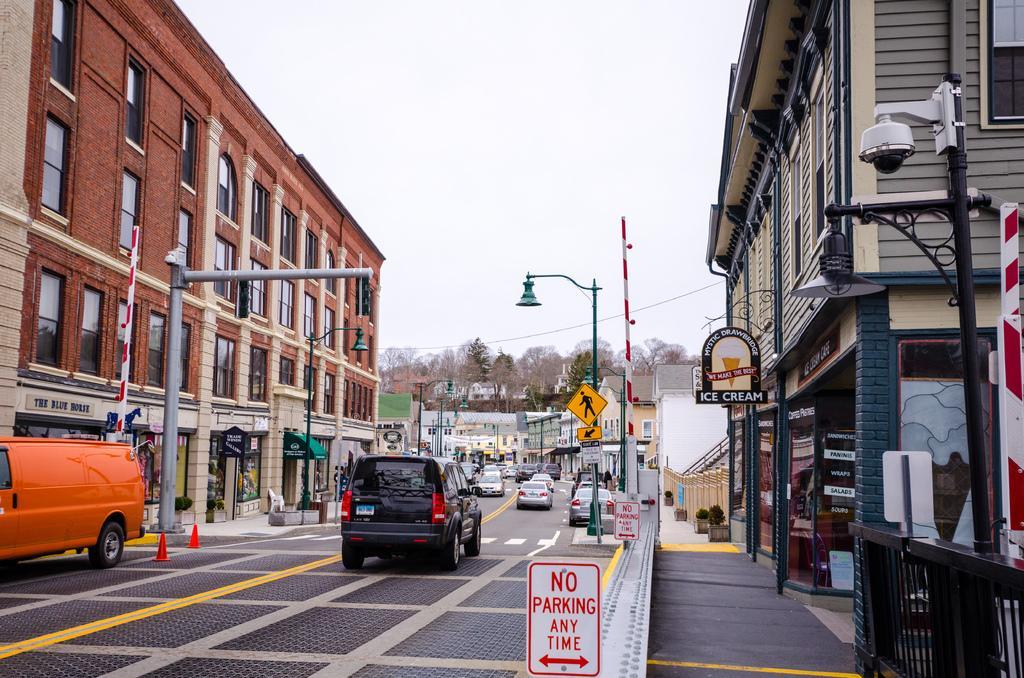Could you give a brief overview of what you see in this image? In this picture I can see few vehicles are on the road, side there are some buildings and some sign boards. 